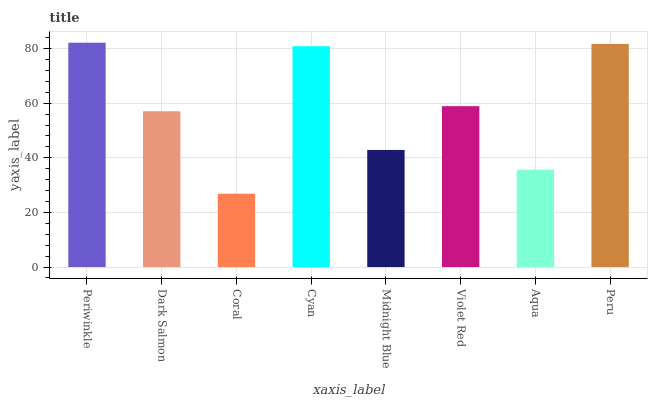Is Coral the minimum?
Answer yes or no. Yes. Is Periwinkle the maximum?
Answer yes or no. Yes. Is Dark Salmon the minimum?
Answer yes or no. No. Is Dark Salmon the maximum?
Answer yes or no. No. Is Periwinkle greater than Dark Salmon?
Answer yes or no. Yes. Is Dark Salmon less than Periwinkle?
Answer yes or no. Yes. Is Dark Salmon greater than Periwinkle?
Answer yes or no. No. Is Periwinkle less than Dark Salmon?
Answer yes or no. No. Is Violet Red the high median?
Answer yes or no. Yes. Is Dark Salmon the low median?
Answer yes or no. Yes. Is Cyan the high median?
Answer yes or no. No. Is Cyan the low median?
Answer yes or no. No. 